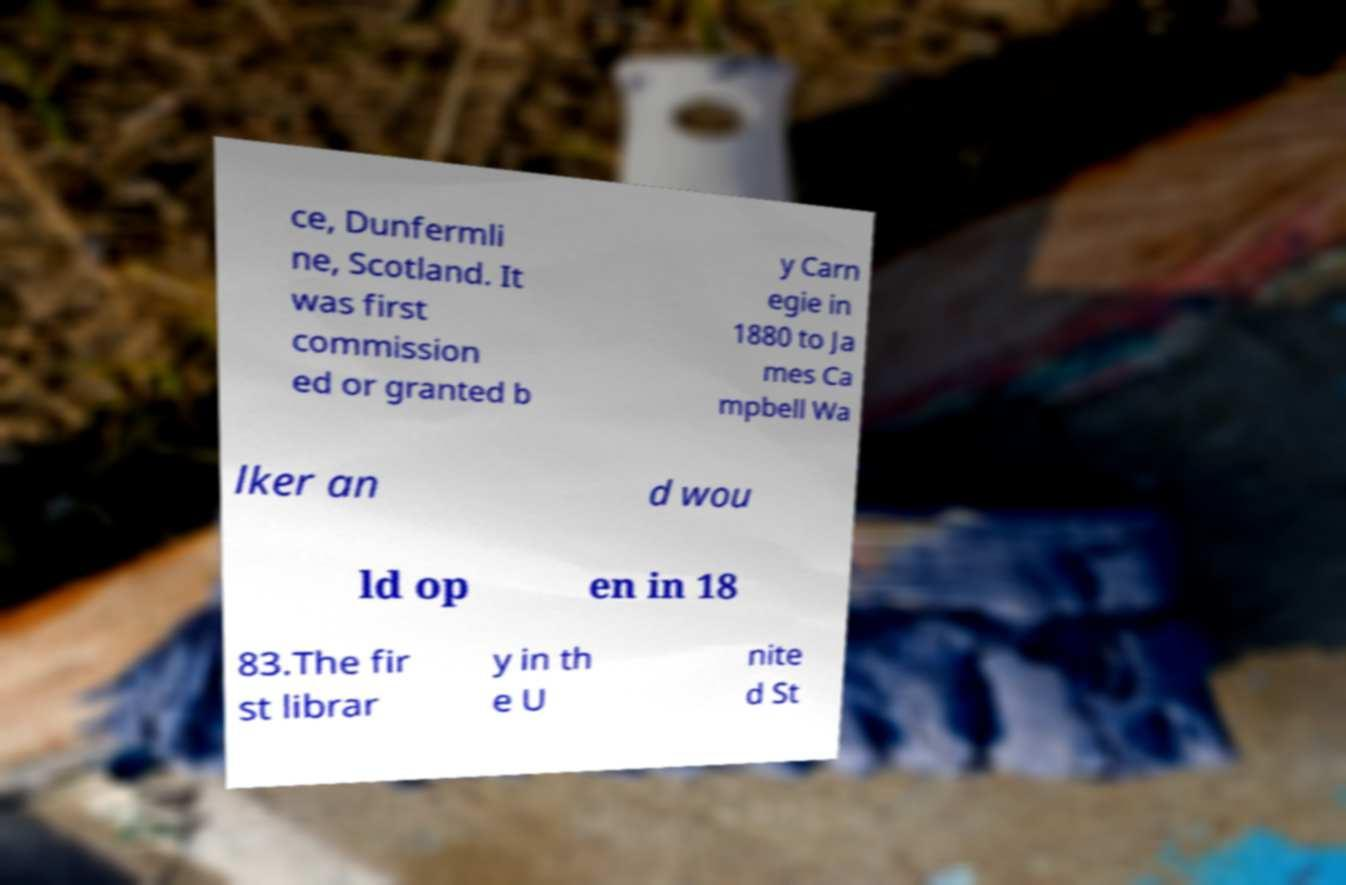There's text embedded in this image that I need extracted. Can you transcribe it verbatim? ce, Dunfermli ne, Scotland. It was first commission ed or granted b y Carn egie in 1880 to Ja mes Ca mpbell Wa lker an d wou ld op en in 18 83.The fir st librar y in th e U nite d St 